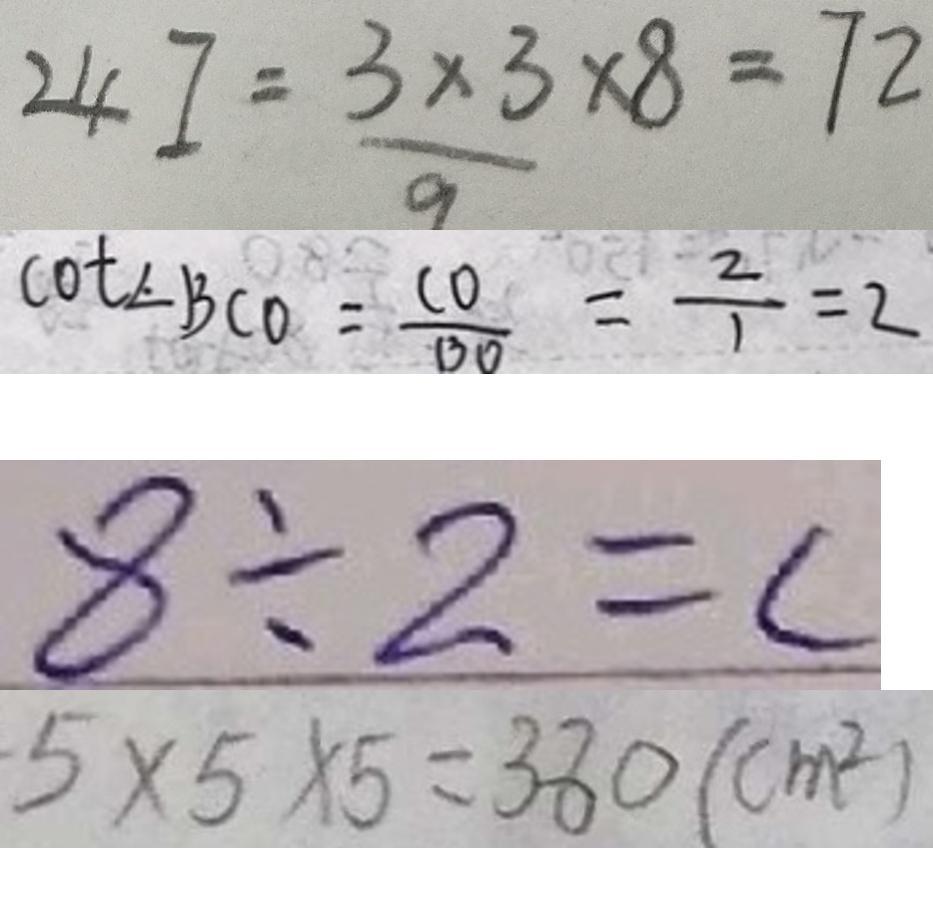<formula> <loc_0><loc_0><loc_500><loc_500>2 4 I = \frac { 3 \times 3 } { 9 } \times 8 = 7 2 
 \cot \angle B C O = \frac { C O } { B O } = \frac { 2 } { 1 } = 2 
 8 \div 2 = c 
 5 \times 5 \times 5 = 3 8 0 ( c m ^ { 2 } )</formula> 